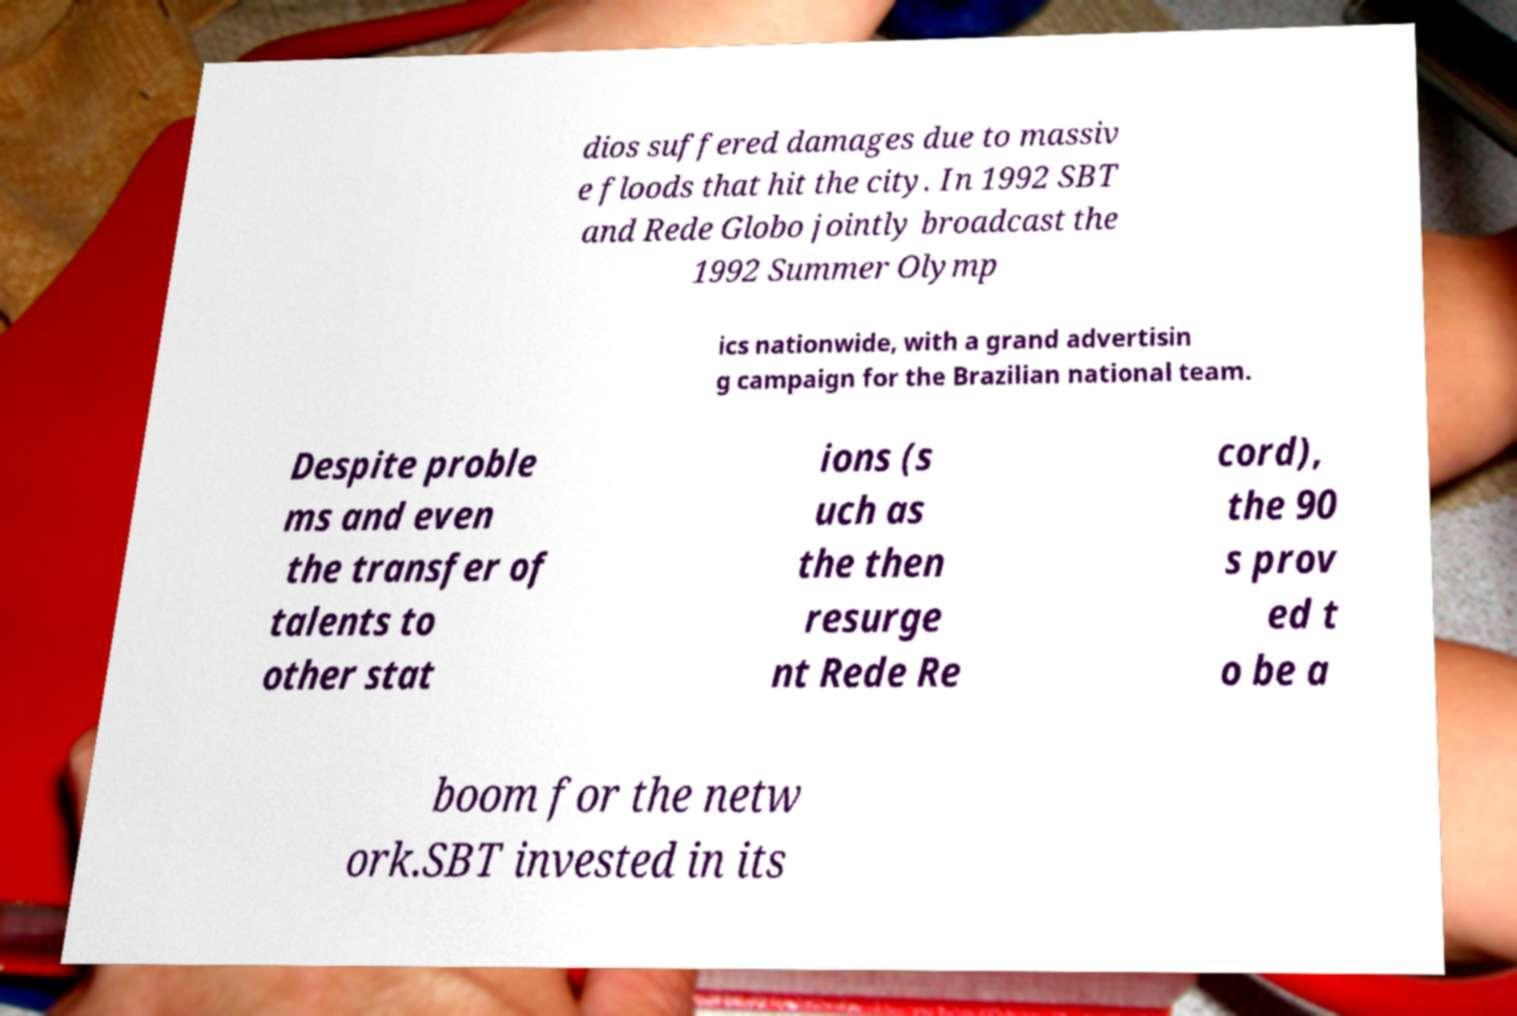Can you accurately transcribe the text from the provided image for me? dios suffered damages due to massiv e floods that hit the city. In 1992 SBT and Rede Globo jointly broadcast the 1992 Summer Olymp ics nationwide, with a grand advertisin g campaign for the Brazilian national team. Despite proble ms and even the transfer of talents to other stat ions (s uch as the then resurge nt Rede Re cord), the 90 s prov ed t o be a boom for the netw ork.SBT invested in its 